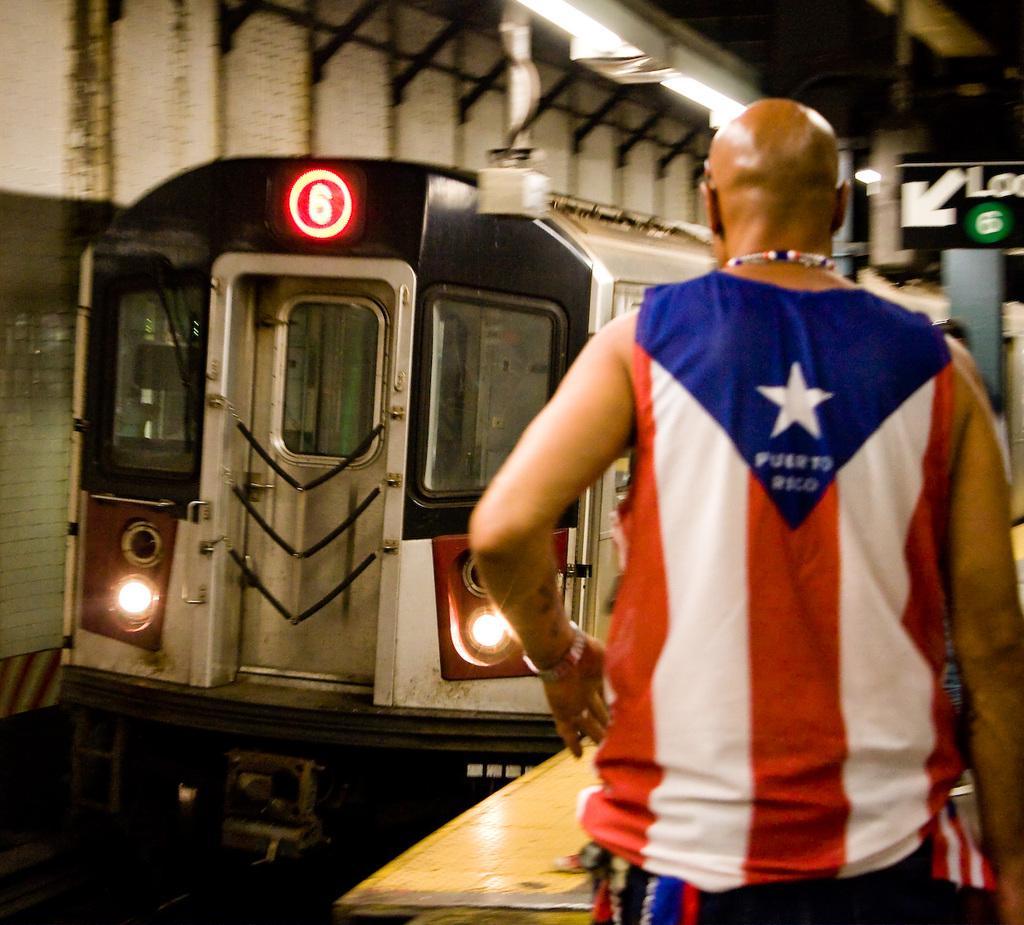Can you describe this image briefly? In this image in front there is a person. In the center of the image there is a train. On the right side of the image there is a sign board. On top of the image there are lights. 